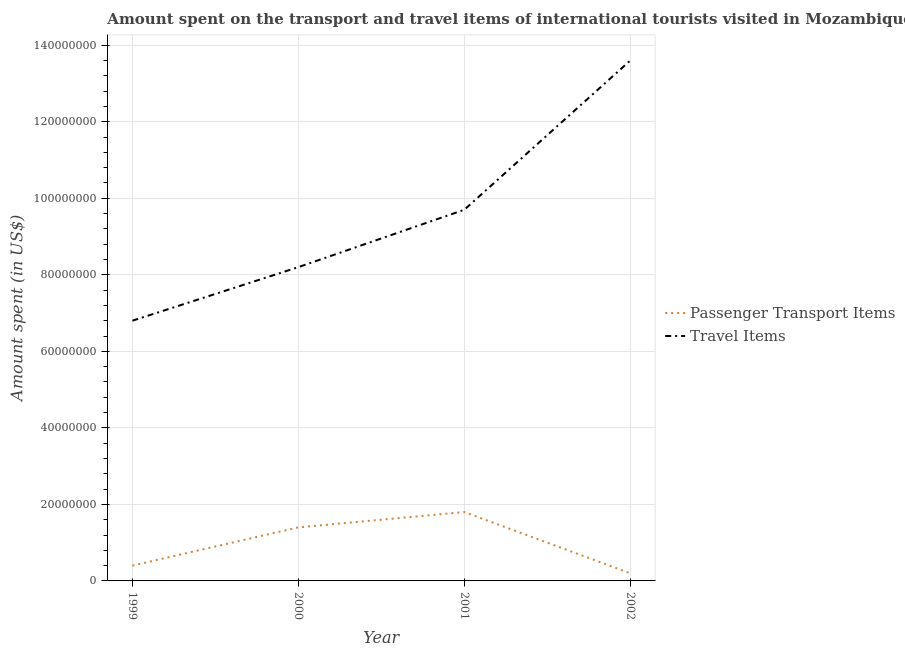How many different coloured lines are there?
Make the answer very short. 2. Is the number of lines equal to the number of legend labels?
Your answer should be compact. Yes. What is the amount spent on passenger transport items in 2002?
Your answer should be compact. 2.00e+06. Across all years, what is the maximum amount spent on passenger transport items?
Your answer should be compact. 1.80e+07. Across all years, what is the minimum amount spent in travel items?
Ensure brevity in your answer.  6.80e+07. What is the total amount spent on passenger transport items in the graph?
Keep it short and to the point. 3.80e+07. What is the difference between the amount spent in travel items in 2001 and that in 2002?
Give a very brief answer. -3.90e+07. What is the difference between the amount spent on passenger transport items in 1999 and the amount spent in travel items in 2001?
Your response must be concise. -9.30e+07. What is the average amount spent in travel items per year?
Provide a succinct answer. 9.58e+07. In the year 1999, what is the difference between the amount spent on passenger transport items and amount spent in travel items?
Your answer should be very brief. -6.40e+07. What is the ratio of the amount spent on passenger transport items in 1999 to that in 2000?
Provide a succinct answer. 0.29. What is the difference between the highest and the second highest amount spent in travel items?
Offer a very short reply. 3.90e+07. What is the difference between the highest and the lowest amount spent in travel items?
Your answer should be compact. 6.80e+07. In how many years, is the amount spent on passenger transport items greater than the average amount spent on passenger transport items taken over all years?
Your answer should be compact. 2. Is the sum of the amount spent in travel items in 2000 and 2002 greater than the maximum amount spent on passenger transport items across all years?
Make the answer very short. Yes. Does the amount spent on passenger transport items monotonically increase over the years?
Give a very brief answer. No. Is the amount spent on passenger transport items strictly greater than the amount spent in travel items over the years?
Keep it short and to the point. No. Is the amount spent in travel items strictly less than the amount spent on passenger transport items over the years?
Your answer should be very brief. No. Does the graph contain any zero values?
Your answer should be compact. No. Where does the legend appear in the graph?
Your answer should be very brief. Center right. How are the legend labels stacked?
Provide a succinct answer. Vertical. What is the title of the graph?
Provide a succinct answer. Amount spent on the transport and travel items of international tourists visited in Mozambique. Does "Borrowers" appear as one of the legend labels in the graph?
Ensure brevity in your answer.  No. What is the label or title of the Y-axis?
Offer a very short reply. Amount spent (in US$). What is the Amount spent (in US$) of Passenger Transport Items in 1999?
Your answer should be very brief. 4.00e+06. What is the Amount spent (in US$) in Travel Items in 1999?
Give a very brief answer. 6.80e+07. What is the Amount spent (in US$) of Passenger Transport Items in 2000?
Give a very brief answer. 1.40e+07. What is the Amount spent (in US$) of Travel Items in 2000?
Give a very brief answer. 8.20e+07. What is the Amount spent (in US$) in Passenger Transport Items in 2001?
Give a very brief answer. 1.80e+07. What is the Amount spent (in US$) in Travel Items in 2001?
Your answer should be compact. 9.70e+07. What is the Amount spent (in US$) in Passenger Transport Items in 2002?
Your response must be concise. 2.00e+06. What is the Amount spent (in US$) of Travel Items in 2002?
Provide a short and direct response. 1.36e+08. Across all years, what is the maximum Amount spent (in US$) of Passenger Transport Items?
Ensure brevity in your answer.  1.80e+07. Across all years, what is the maximum Amount spent (in US$) in Travel Items?
Provide a succinct answer. 1.36e+08. Across all years, what is the minimum Amount spent (in US$) in Passenger Transport Items?
Your answer should be compact. 2.00e+06. Across all years, what is the minimum Amount spent (in US$) of Travel Items?
Your response must be concise. 6.80e+07. What is the total Amount spent (in US$) in Passenger Transport Items in the graph?
Make the answer very short. 3.80e+07. What is the total Amount spent (in US$) in Travel Items in the graph?
Ensure brevity in your answer.  3.83e+08. What is the difference between the Amount spent (in US$) of Passenger Transport Items in 1999 and that in 2000?
Ensure brevity in your answer.  -1.00e+07. What is the difference between the Amount spent (in US$) in Travel Items in 1999 and that in 2000?
Ensure brevity in your answer.  -1.40e+07. What is the difference between the Amount spent (in US$) in Passenger Transport Items in 1999 and that in 2001?
Provide a short and direct response. -1.40e+07. What is the difference between the Amount spent (in US$) of Travel Items in 1999 and that in 2001?
Offer a very short reply. -2.90e+07. What is the difference between the Amount spent (in US$) of Travel Items in 1999 and that in 2002?
Offer a terse response. -6.80e+07. What is the difference between the Amount spent (in US$) of Travel Items in 2000 and that in 2001?
Keep it short and to the point. -1.50e+07. What is the difference between the Amount spent (in US$) in Travel Items in 2000 and that in 2002?
Give a very brief answer. -5.40e+07. What is the difference between the Amount spent (in US$) of Passenger Transport Items in 2001 and that in 2002?
Offer a very short reply. 1.60e+07. What is the difference between the Amount spent (in US$) in Travel Items in 2001 and that in 2002?
Your answer should be compact. -3.90e+07. What is the difference between the Amount spent (in US$) in Passenger Transport Items in 1999 and the Amount spent (in US$) in Travel Items in 2000?
Keep it short and to the point. -7.80e+07. What is the difference between the Amount spent (in US$) in Passenger Transport Items in 1999 and the Amount spent (in US$) in Travel Items in 2001?
Offer a terse response. -9.30e+07. What is the difference between the Amount spent (in US$) of Passenger Transport Items in 1999 and the Amount spent (in US$) of Travel Items in 2002?
Your response must be concise. -1.32e+08. What is the difference between the Amount spent (in US$) of Passenger Transport Items in 2000 and the Amount spent (in US$) of Travel Items in 2001?
Keep it short and to the point. -8.30e+07. What is the difference between the Amount spent (in US$) in Passenger Transport Items in 2000 and the Amount spent (in US$) in Travel Items in 2002?
Ensure brevity in your answer.  -1.22e+08. What is the difference between the Amount spent (in US$) in Passenger Transport Items in 2001 and the Amount spent (in US$) in Travel Items in 2002?
Ensure brevity in your answer.  -1.18e+08. What is the average Amount spent (in US$) in Passenger Transport Items per year?
Provide a succinct answer. 9.50e+06. What is the average Amount spent (in US$) in Travel Items per year?
Offer a terse response. 9.58e+07. In the year 1999, what is the difference between the Amount spent (in US$) in Passenger Transport Items and Amount spent (in US$) in Travel Items?
Give a very brief answer. -6.40e+07. In the year 2000, what is the difference between the Amount spent (in US$) of Passenger Transport Items and Amount spent (in US$) of Travel Items?
Your answer should be compact. -6.80e+07. In the year 2001, what is the difference between the Amount spent (in US$) in Passenger Transport Items and Amount spent (in US$) in Travel Items?
Offer a very short reply. -7.90e+07. In the year 2002, what is the difference between the Amount spent (in US$) in Passenger Transport Items and Amount spent (in US$) in Travel Items?
Provide a succinct answer. -1.34e+08. What is the ratio of the Amount spent (in US$) of Passenger Transport Items in 1999 to that in 2000?
Your response must be concise. 0.29. What is the ratio of the Amount spent (in US$) in Travel Items in 1999 to that in 2000?
Ensure brevity in your answer.  0.83. What is the ratio of the Amount spent (in US$) of Passenger Transport Items in 1999 to that in 2001?
Give a very brief answer. 0.22. What is the ratio of the Amount spent (in US$) in Travel Items in 1999 to that in 2001?
Your answer should be very brief. 0.7. What is the ratio of the Amount spent (in US$) of Passenger Transport Items in 1999 to that in 2002?
Ensure brevity in your answer.  2. What is the ratio of the Amount spent (in US$) in Travel Items in 2000 to that in 2001?
Ensure brevity in your answer.  0.85. What is the ratio of the Amount spent (in US$) of Travel Items in 2000 to that in 2002?
Offer a very short reply. 0.6. What is the ratio of the Amount spent (in US$) in Travel Items in 2001 to that in 2002?
Make the answer very short. 0.71. What is the difference between the highest and the second highest Amount spent (in US$) of Passenger Transport Items?
Offer a terse response. 4.00e+06. What is the difference between the highest and the second highest Amount spent (in US$) of Travel Items?
Offer a very short reply. 3.90e+07. What is the difference between the highest and the lowest Amount spent (in US$) in Passenger Transport Items?
Your answer should be very brief. 1.60e+07. What is the difference between the highest and the lowest Amount spent (in US$) of Travel Items?
Your response must be concise. 6.80e+07. 